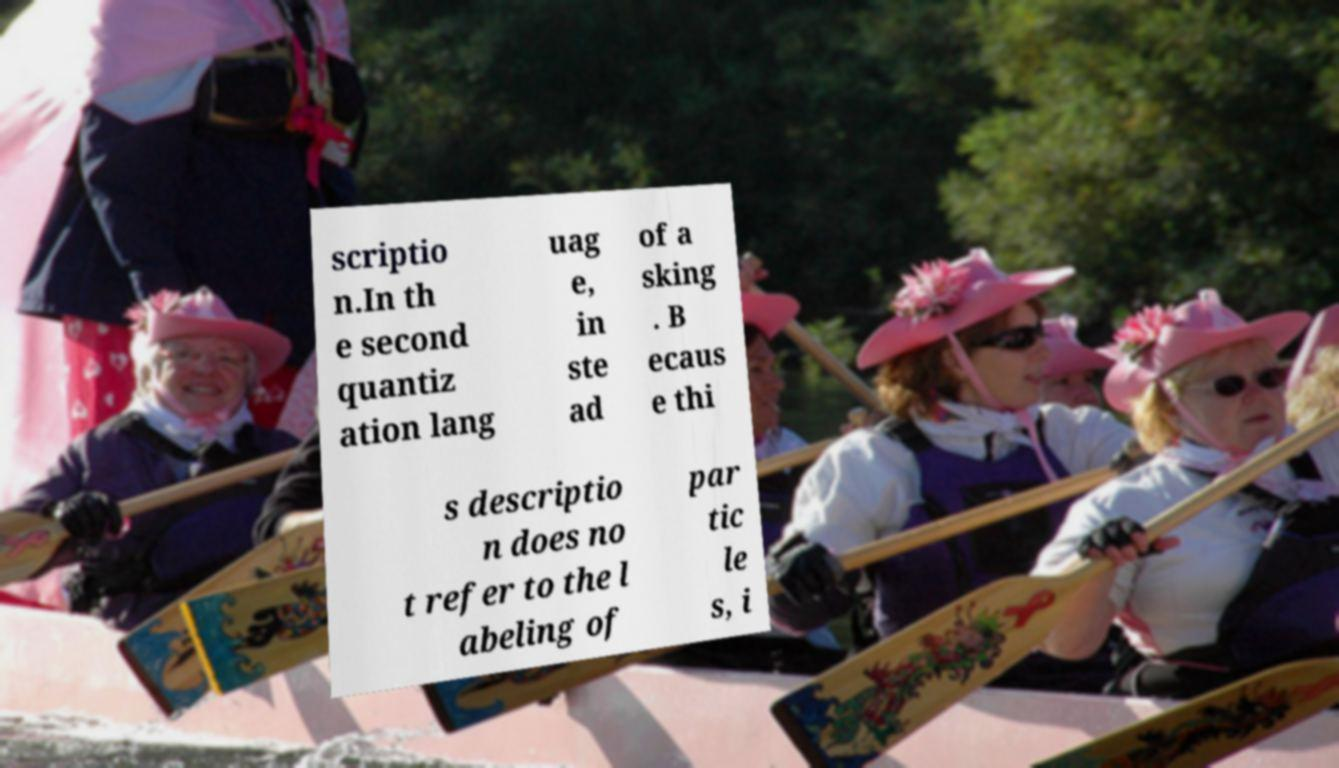Could you assist in decoding the text presented in this image and type it out clearly? scriptio n.In th e second quantiz ation lang uag e, in ste ad of a sking . B ecaus e thi s descriptio n does no t refer to the l abeling of par tic le s, i 